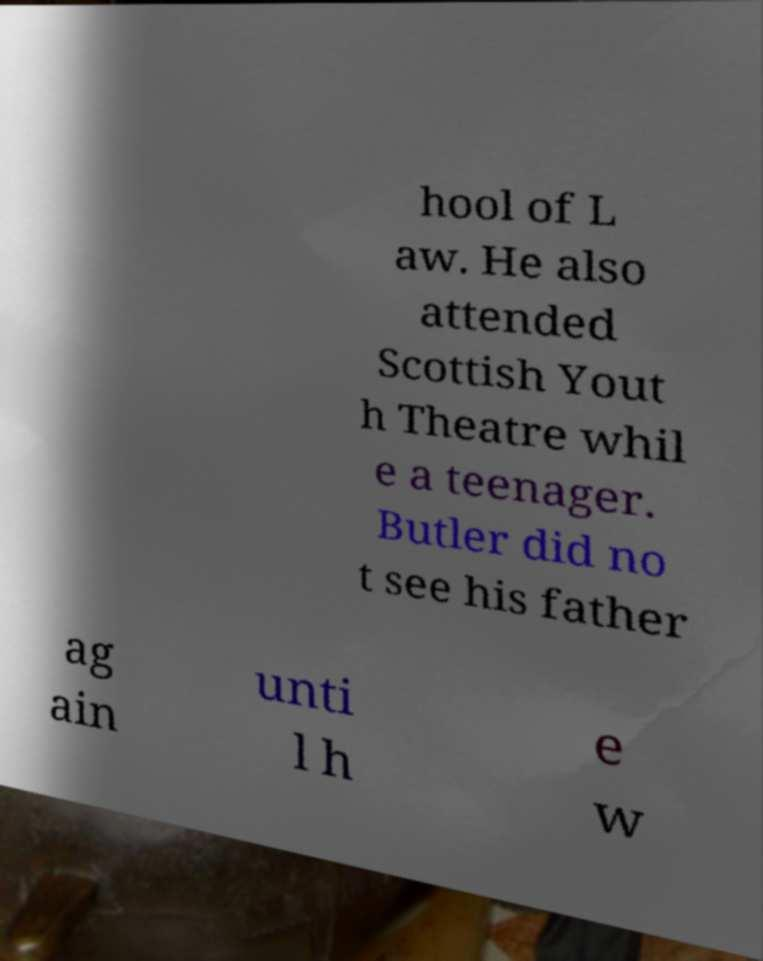Can you accurately transcribe the text from the provided image for me? hool of L aw. He also attended Scottish Yout h Theatre whil e a teenager. Butler did no t see his father ag ain unti l h e w 